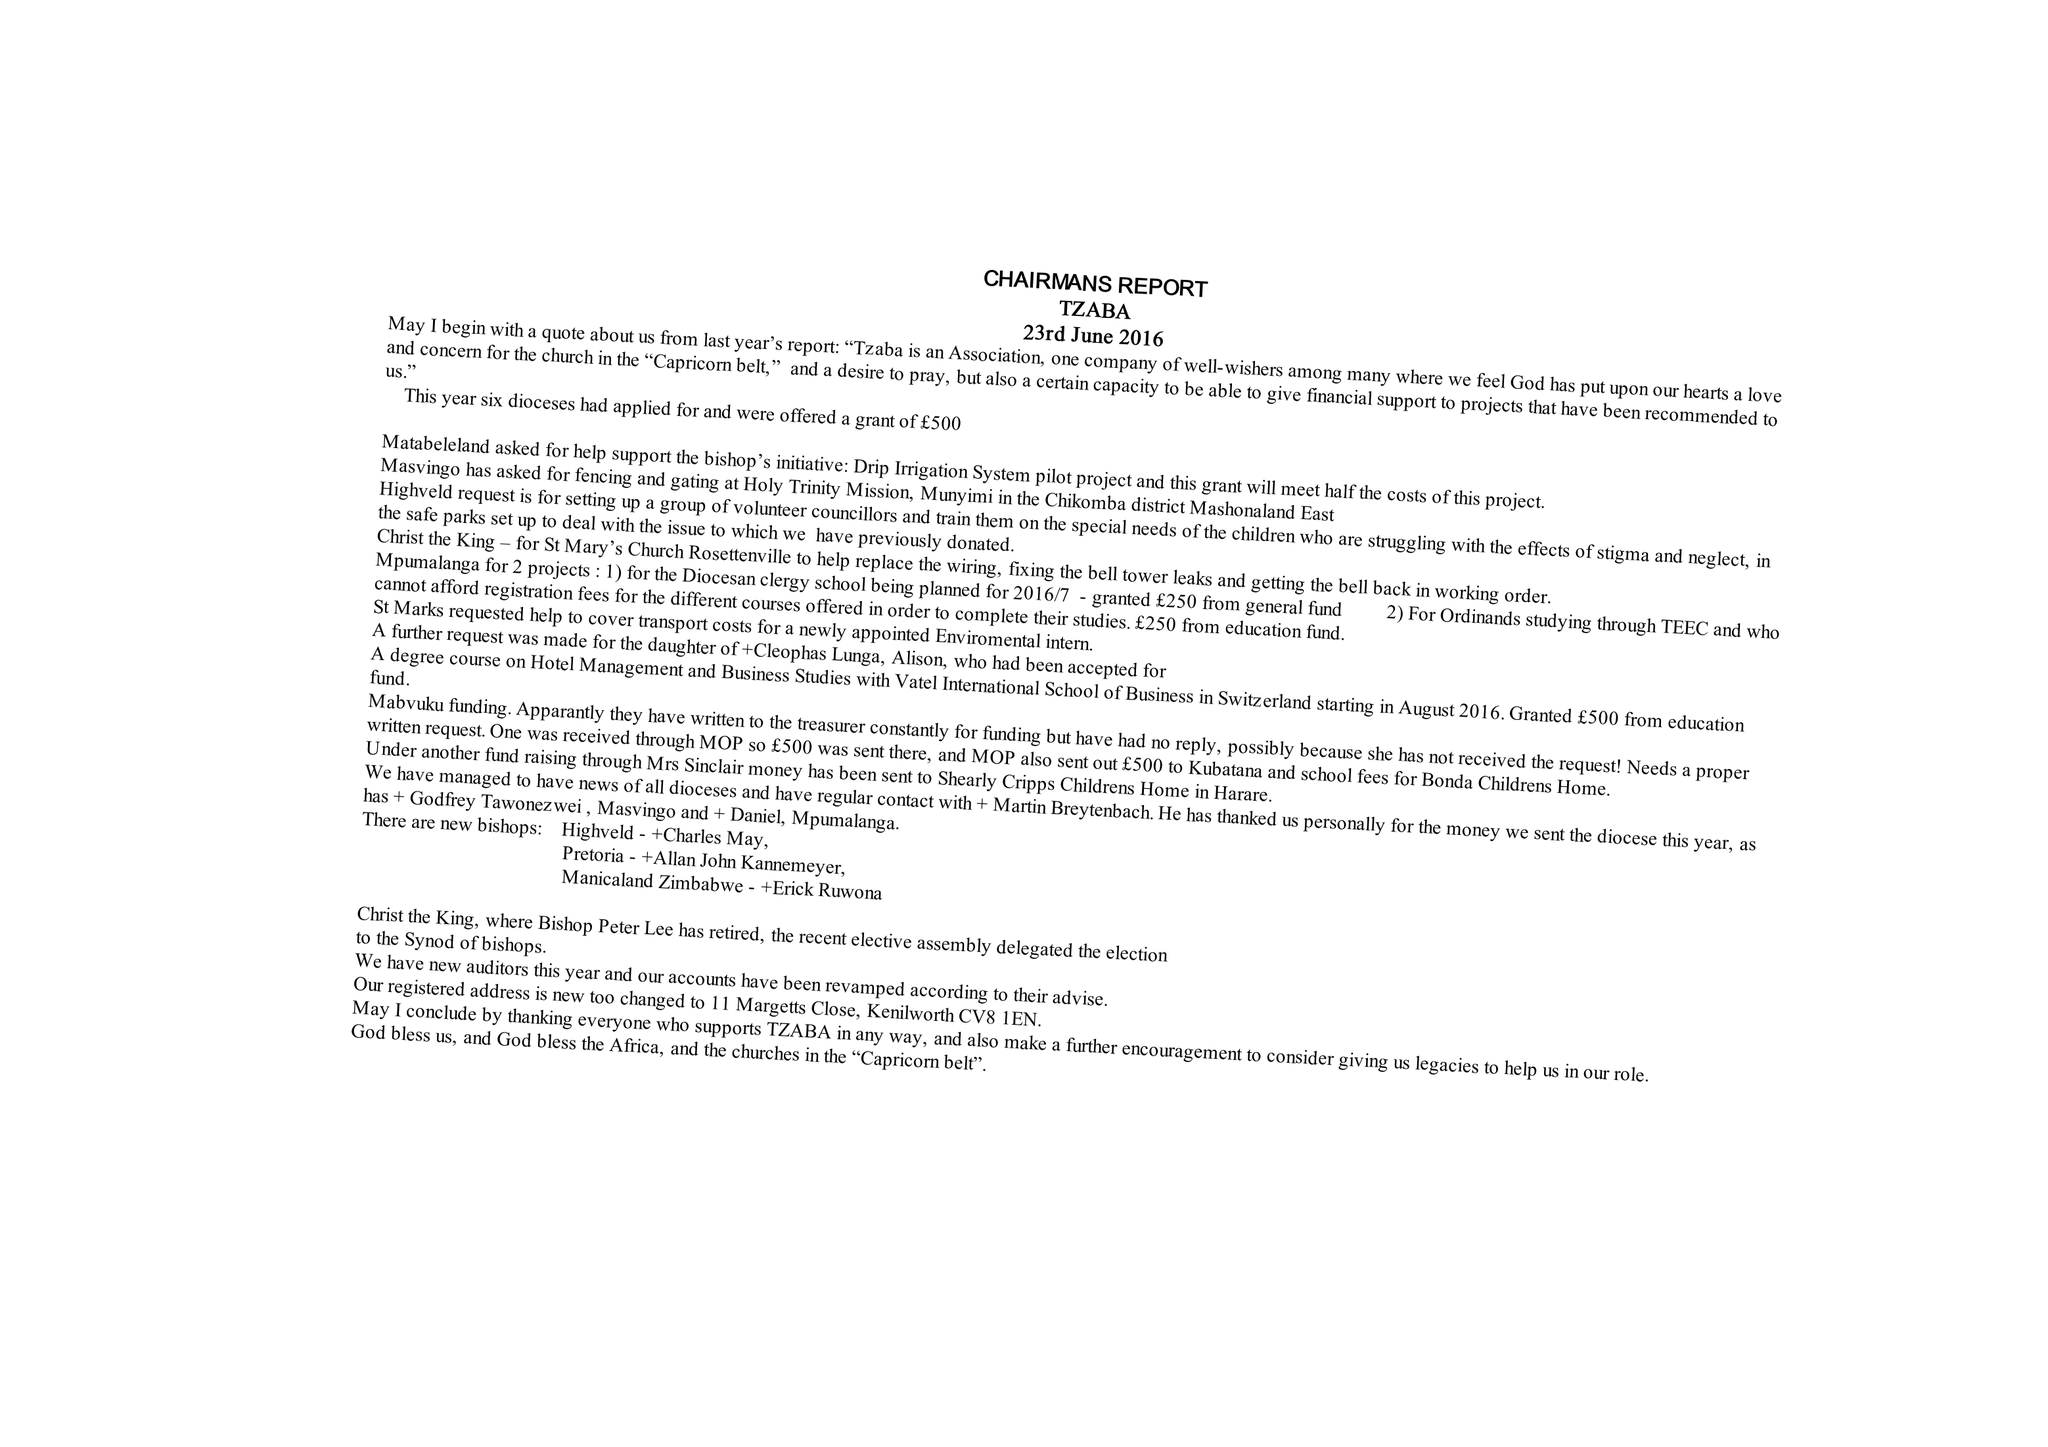What is the value for the charity_name?
Answer the question using a single word or phrase. Transvaal Zimbabwe and Botswana Association 